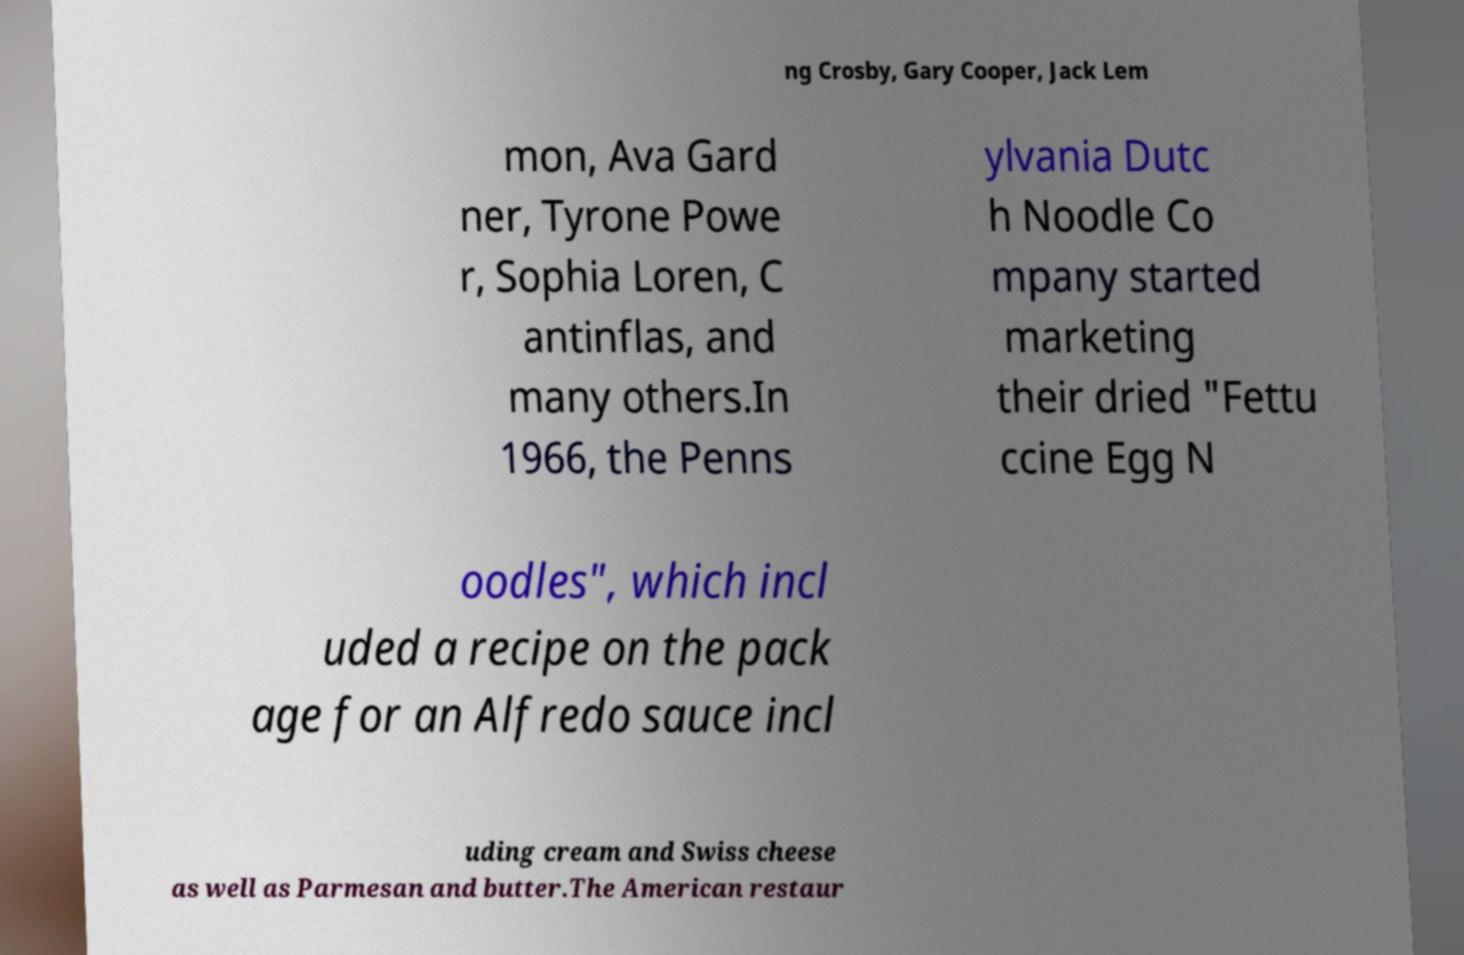There's text embedded in this image that I need extracted. Can you transcribe it verbatim? ng Crosby, Gary Cooper, Jack Lem mon, Ava Gard ner, Tyrone Powe r, Sophia Loren, C antinflas, and many others.In 1966, the Penns ylvania Dutc h Noodle Co mpany started marketing their dried "Fettu ccine Egg N oodles", which incl uded a recipe on the pack age for an Alfredo sauce incl uding cream and Swiss cheese as well as Parmesan and butter.The American restaur 